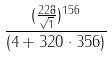Convert formula to latex. <formula><loc_0><loc_0><loc_500><loc_500>\frac { ( \frac { 2 2 8 } { \sqrt { 1 } } ) ^ { 1 5 6 } } { ( 4 + 3 2 0 \cdot 3 5 6 ) }</formula> 